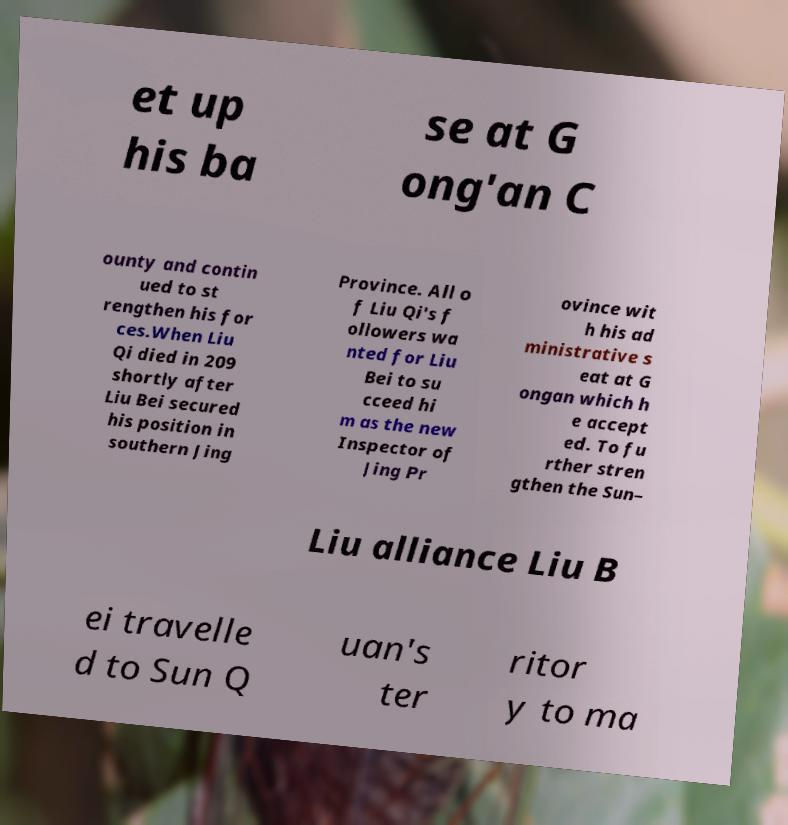Please read and relay the text visible in this image. What does it say? et up his ba se at G ong'an C ounty and contin ued to st rengthen his for ces.When Liu Qi died in 209 shortly after Liu Bei secured his position in southern Jing Province. All o f Liu Qi's f ollowers wa nted for Liu Bei to su cceed hi m as the new Inspector of Jing Pr ovince wit h his ad ministrative s eat at G ongan which h e accept ed. To fu rther stren gthen the Sun– Liu alliance Liu B ei travelle d to Sun Q uan's ter ritor y to ma 